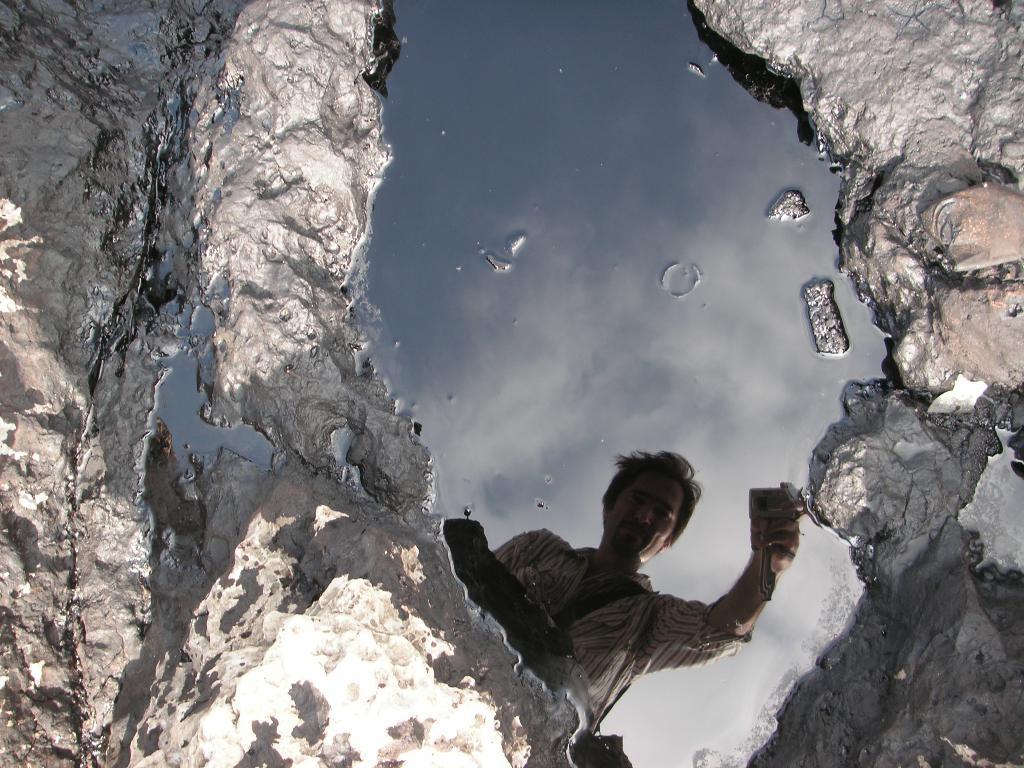How would you summarize this image in a sentence or two? In this image we can see there are some water. In the water there is a reflection of a person. 